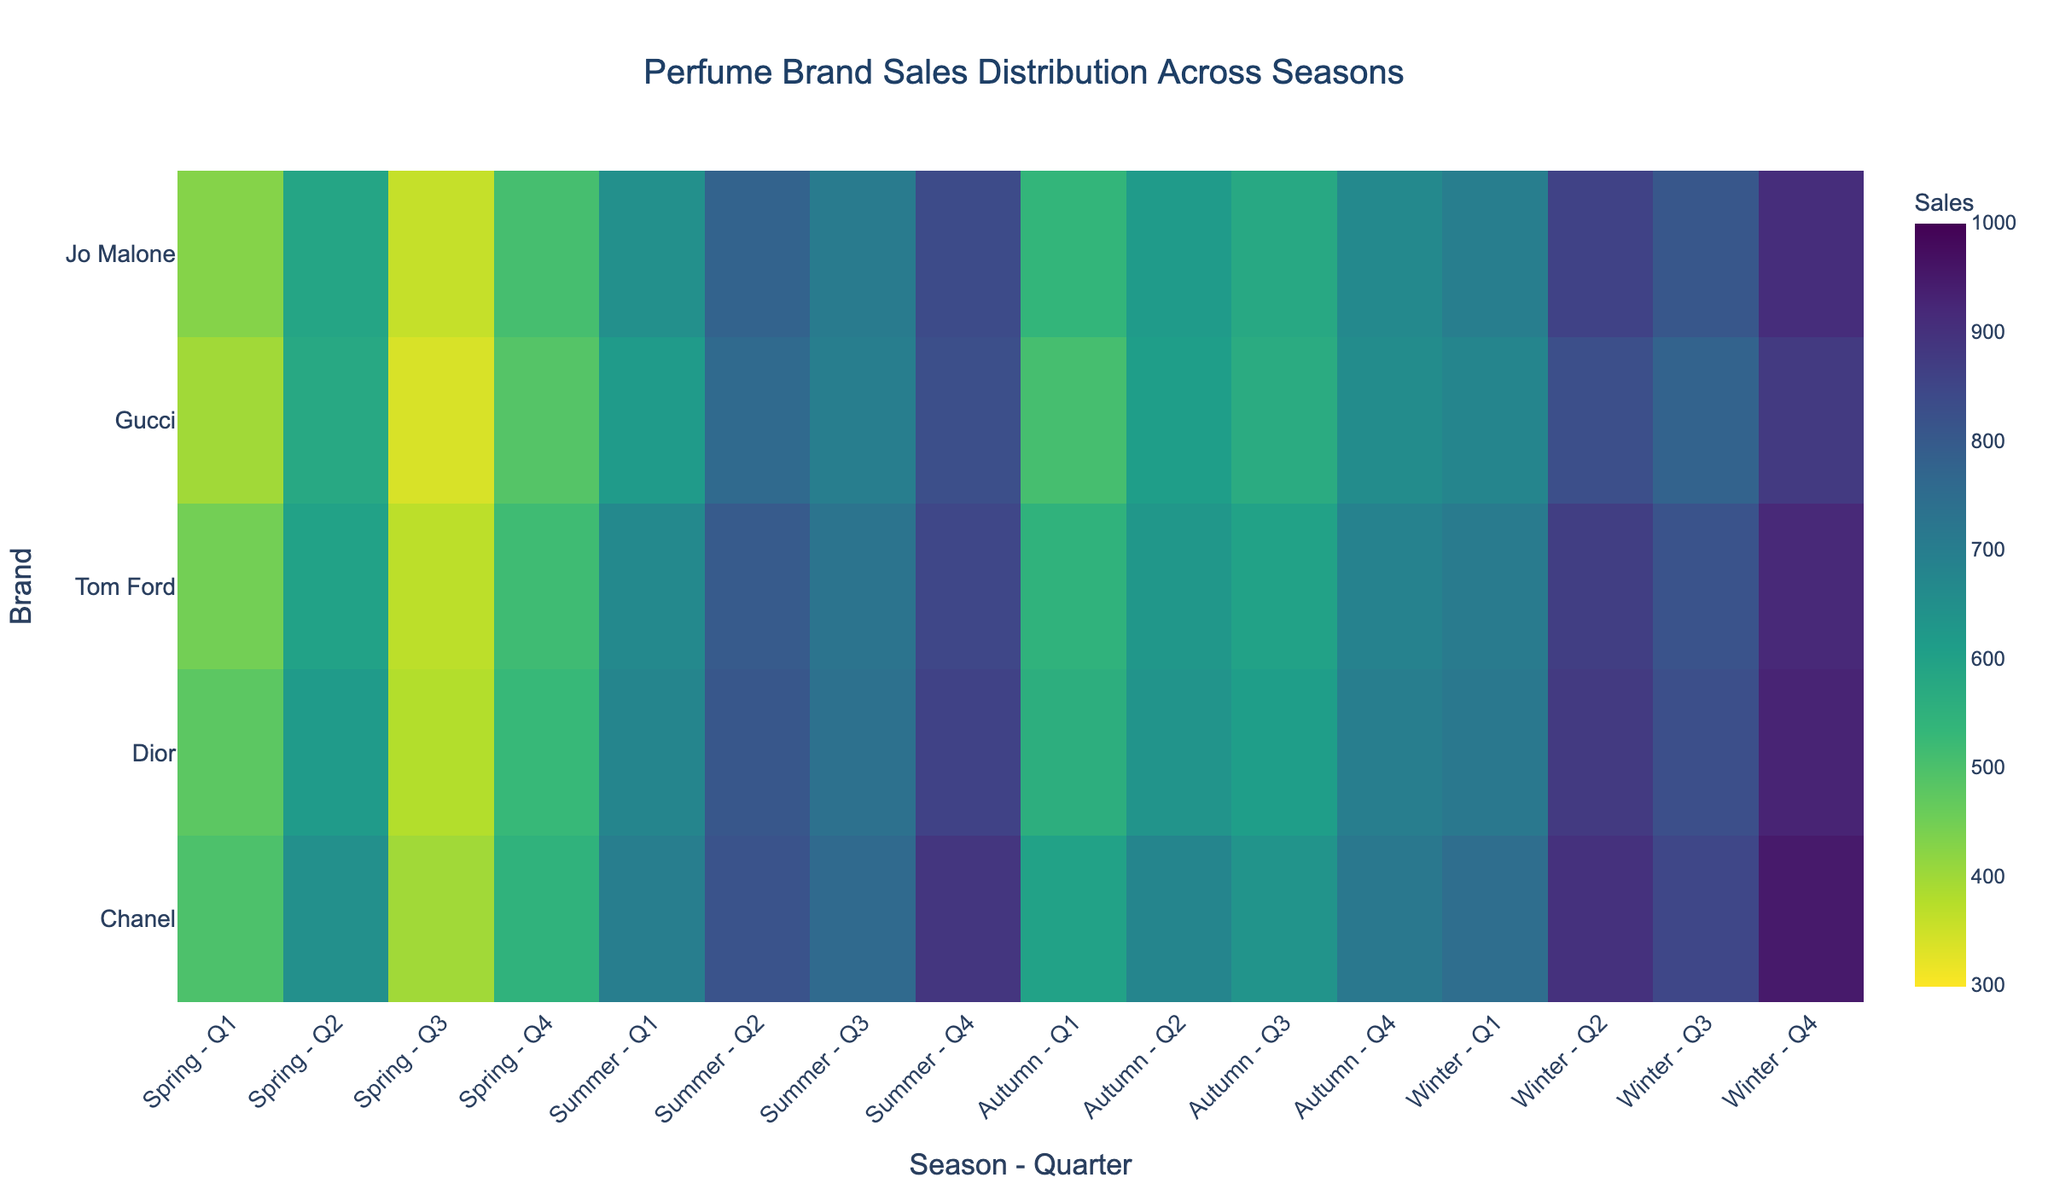What is the total sales of Chanel during Summer? To find the total sales of Chanel during Summer, sum the values from the four quarters: 700 + 820 + 760 + 890. Thus, the answer is 3170.
Answer: 3170 Which brand has the highest sales in Winter, and what are the sales figures? Look at the Winter row for each brand and identify the highest value. Chanel has the highest sales in Q4 Winter with 950 units.
Answer: Chanel, 950 How does the average sales in Autumn for Dior compare to that for Gucci? Calculate the average sales for Dior and Gucci in Autumn. For Dior: (560 + 640 + 610 + 700)/4 = 627.5. For Gucci: (510 + 610 + 570 + 660)/4 = 587.5. Compare the two averages, the difference is 40 units.
Answer: Dior’s average is 40 units higher than Gucci's Which brand has the lowest sales during Spring, and what are the figures? Identify the lowest value in the Spring row across all brands. Gucci has the lowest value with 340 units in Q3 Spring.
Answer: Gucci, 340 What is the sales trend for Tom Ford from Spring to Winter? Observing Tom Ford across all seasons: Spring (450, 600, 370, 520), Summer (670, 800, 730, 850), Autumn (550, 630, 600, 690), Winter (710, 870, 820, 920), there is an increasing trend in sales.
Answer: Increasing trend Which quarter and season have the highest sales for Jo Malone? Look for the highest value in Jo Malone's row. The highest sales for Jo Malone is in Q4 Summer with 840 units.
Answer: Q4 Summer Between Chanel and Dior, which has higher sales in Q3 Winter, and how much higher? Compare the sales figures for Q3 Winter between Chanel (850) and Dior (830). Chanel has higher sales by 20 units.
Answer: Chanel, 20 units higher What is the variance in sales for Gucci during Autumn? Variance is the average of the squared differences from the mean. For Gucci in Autumn (510, 610, 570, 660): Mean = (510+610+570+660)/4 = 587.5. Variance = [(510 - 587.5)^2 + (610 - 587.5)^2 + (570 - 587.5)^2 + (660 - 587.5)^2]/4 = 3906.25.
Answer: 3906.25 What seasonal pattern can be observed for Dior's sales? Dior's sales peak during Summer and Winter, with lower values in Spring and Autumn, indicating a seasonal pattern with higher demand in warmer and colder months
Answer: Peak in Summer and Winter 